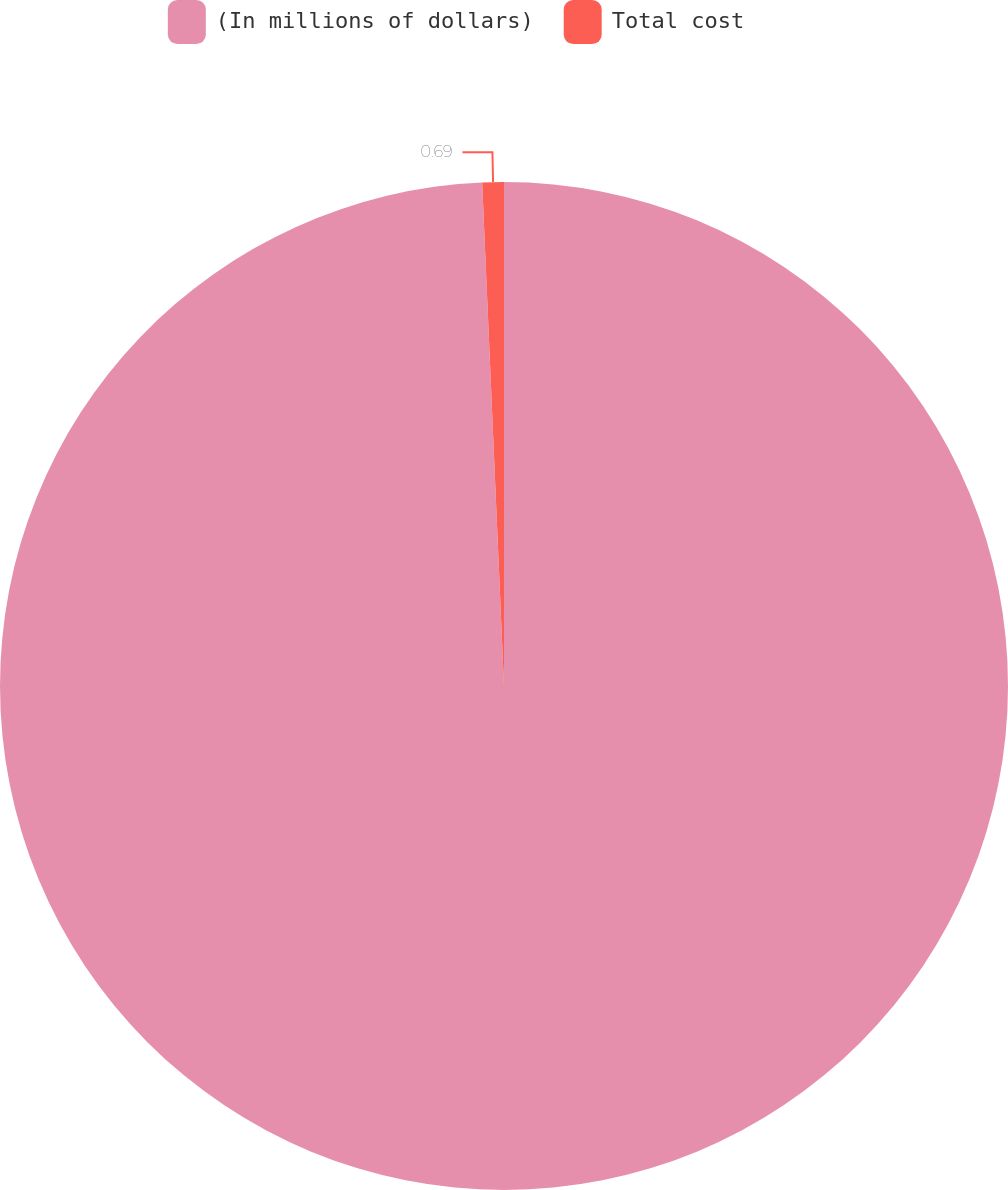<chart> <loc_0><loc_0><loc_500><loc_500><pie_chart><fcel>(In millions of dollars)<fcel>Total cost<nl><fcel>99.31%<fcel>0.69%<nl></chart> 